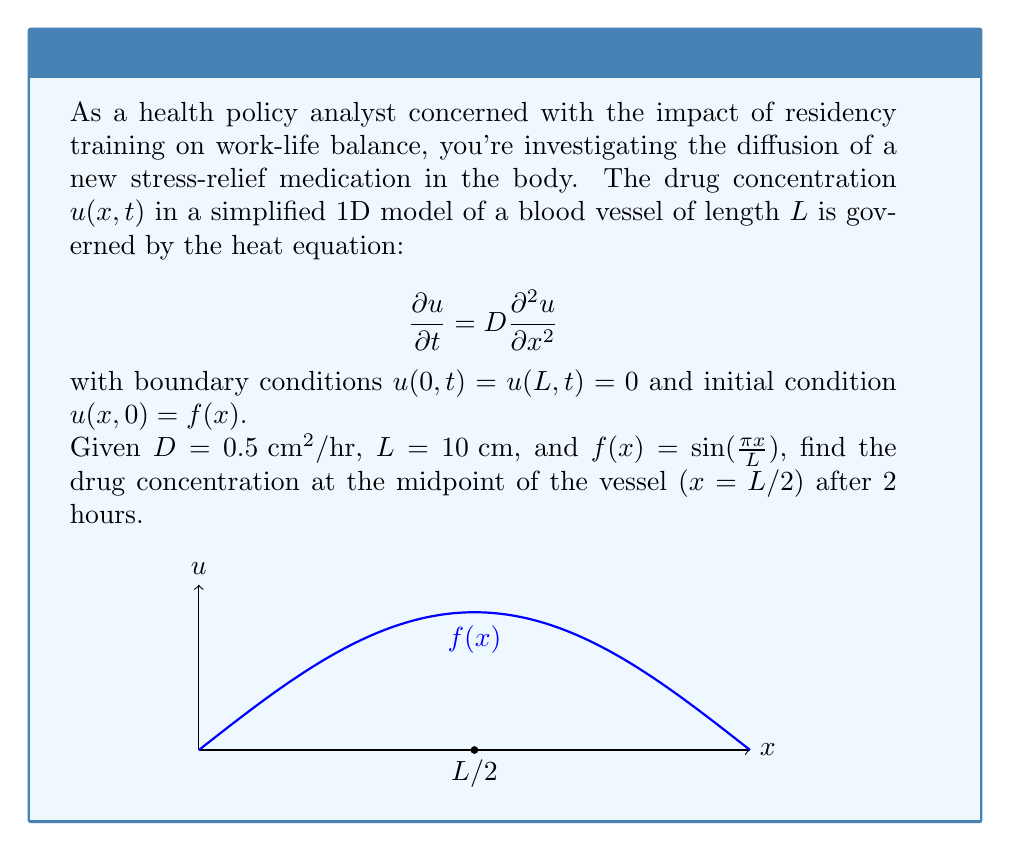Can you answer this question? Let's solve this problem step by step:

1) The general solution to the heat equation with these boundary conditions is:

   $$u(x,t) = \sum_{n=1}^{\infty} B_n \sin(\frac{n\pi x}{L}) e^{-D(\frac{n\pi}{L})^2t}$$

2) The coefficients $B_n$ are determined by the initial condition:

   $$B_n = \frac{2}{L} \int_0^L f(x) \sin(\frac{n\pi x}{L}) dx$$

3) In our case, $f(x) = \sin(\frac{\pi x}{L})$, so we only need $B_1$:

   $$B_1 = \frac{2}{L} \int_0^L \sin(\frac{\pi x}{L}) \sin(\frac{\pi x}{L}) dx = 1$$

   All other $B_n = 0$ for $n > 1$

4) Therefore, our solution simplifies to:

   $$u(x,t) = \sin(\frac{\pi x}{L}) e^{-D(\frac{\pi}{L})^2t}$$

5) We want to find $u(L/2, 2)$. Let's substitute the values:

   $$u(L/2, 2) = \sin(\frac{\pi (L/2)}{L}) e^{-0.5(\frac{\pi}{10})^2 \cdot 2}$$

6) Simplify:
   
   $$u(5, 2) = \sin(\frac{\pi}{2}) e^{-0.5(\frac{\pi}{10})^2 \cdot 2} = 1 \cdot e^{-0.0493} \approx 0.9519$$
Answer: $0.9519$ 